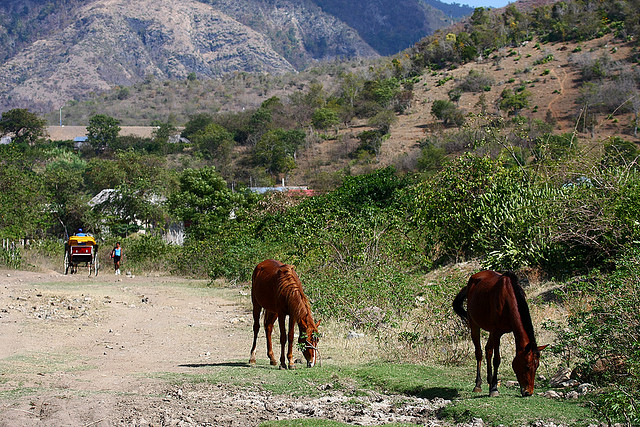<image>What breed is the horse on the right? I don't know the breed of the horse on the right. It could be an Arabian, Tennessee Walker, Clydesdale, Palomino, Quarter Horse, or Mustang. What breed is the horse on the right? I don't know the breed of the horse on the right. It can be Arabian, Tennessee Walker, Brown, Clydesdale, Palomino, Quarter Horse, or Mustang. 